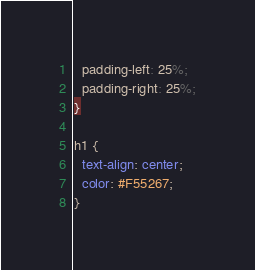Convert code to text. <code><loc_0><loc_0><loc_500><loc_500><_CSS_>  padding-left: 25%;
  padding-right: 25%;
}

h1 {
  text-align: center;
  color: #F55267;
}</code> 